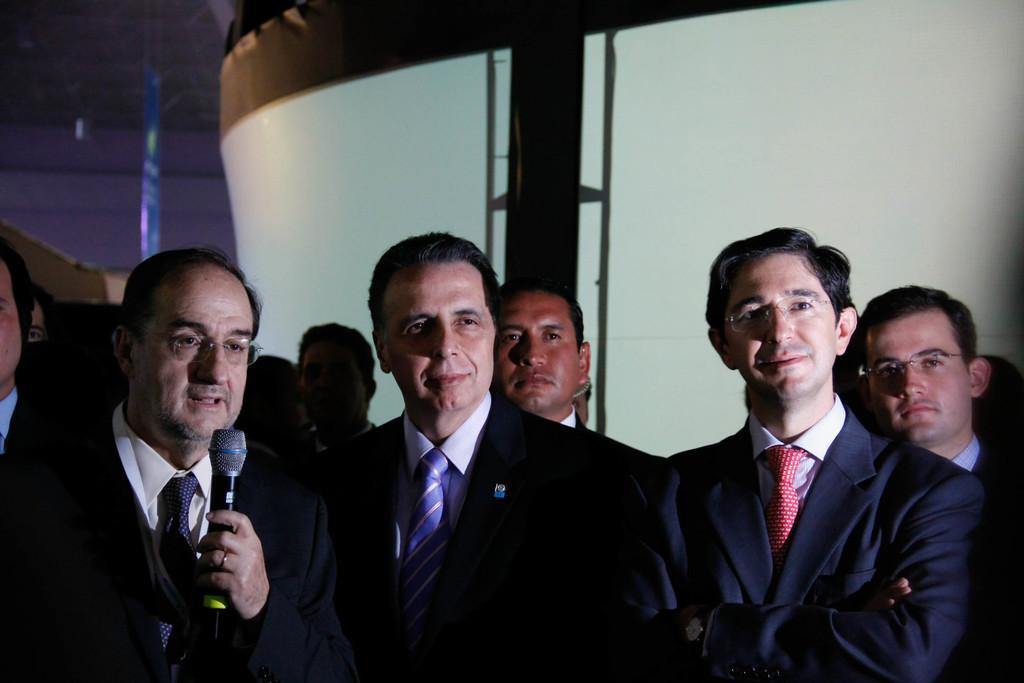Can you describe this image briefly? In this image I see few men, in which this man is holding the mic and all of them are standing. 